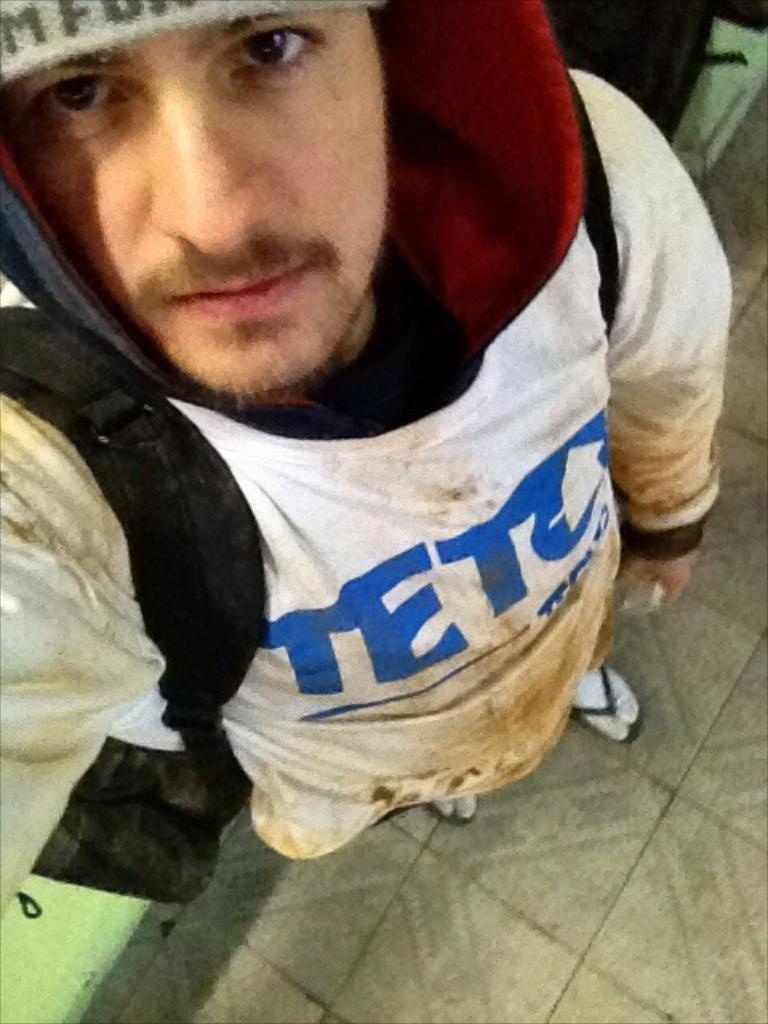<image>
Write a terse but informative summary of the picture. A guy in a dirty white hoodie that says TET something. 